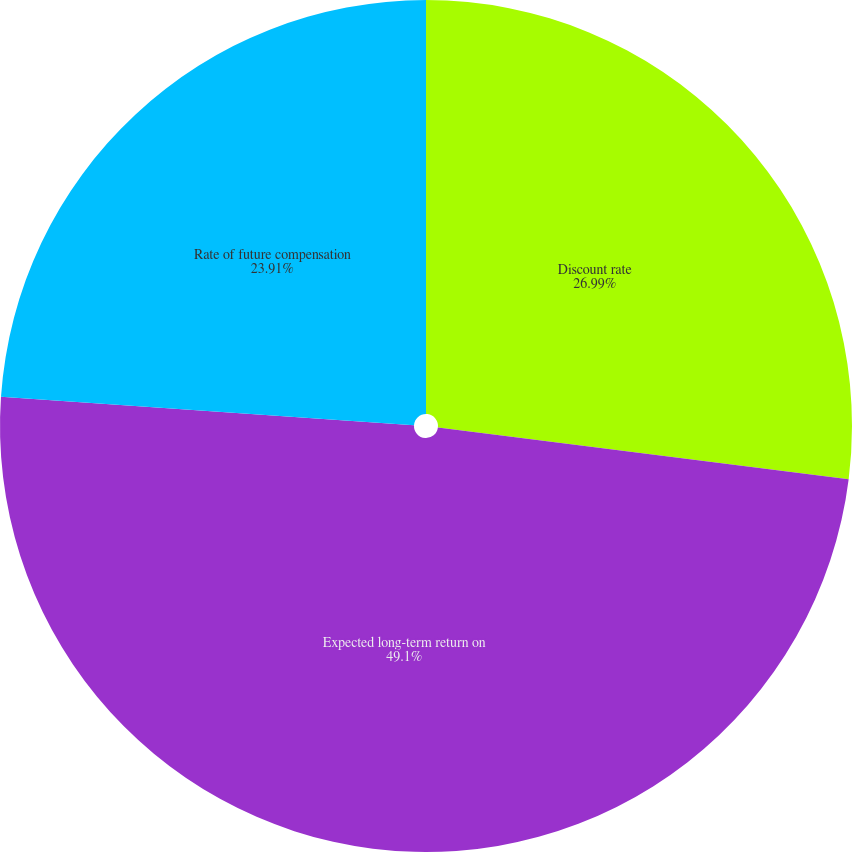Convert chart to OTSL. <chart><loc_0><loc_0><loc_500><loc_500><pie_chart><fcel>Discount rate<fcel>Expected long-term return on<fcel>Rate of future compensation<nl><fcel>26.99%<fcel>49.1%<fcel>23.91%<nl></chart> 